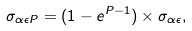<formula> <loc_0><loc_0><loc_500><loc_500>\sigma _ { \alpha \epsilon P } = ( 1 - e ^ { P - 1 } ) \times \sigma _ { \alpha \epsilon } ,</formula> 